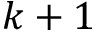<formula> <loc_0><loc_0><loc_500><loc_500>k + 1</formula> 